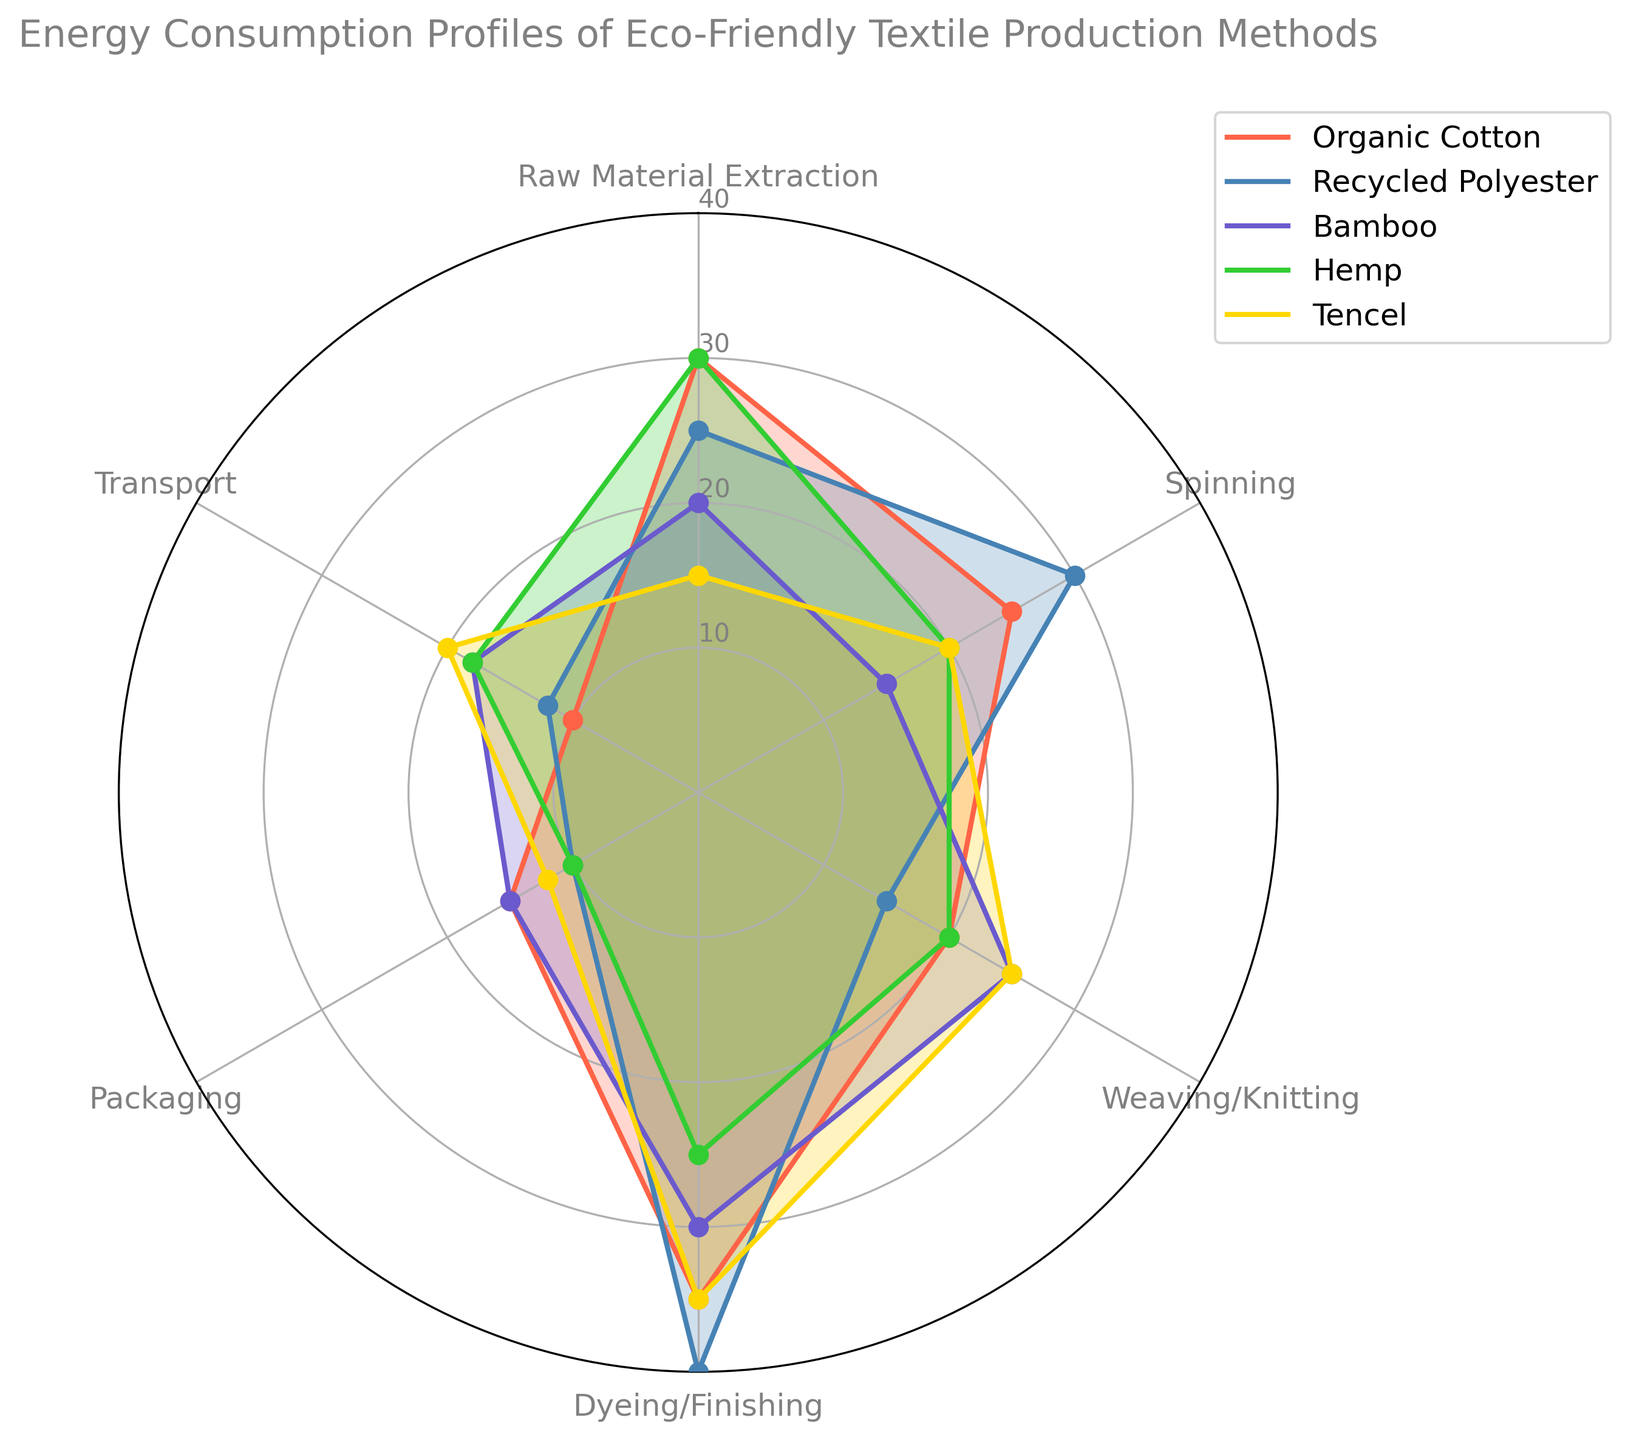What is the energy consumption for raw material extraction for Organic Cotton and Bamboo combined? The energy consumption for raw material extraction in Organic Cotton is 30 and for Bamboo, it is 20. Summing them up gives us 30 + 20 = 50.
Answer: 50 Which textile method has the highest energy consumption in Dyeing/Finishing? In Dyeing/Finishing, the energy consumptions are: Organic Cotton (35), Recycled Polyester (40), Bamboo (30), Hemp (25), Tencel (35). The highest value is 40 for Recycled Polyester.
Answer: Recycled Polyester How does the energy consumption of Tencel in Transport compare to Bamboo in the same process? Tencel has an energy consumption of 20 for Transport, whereas Bamboo has 18 for the same process. 20 is greater than 18.
Answer: Tencel has higher energy consumption What is the average energy consumption across all processes for Hemp? Adding all processes for Hemp (30 + 20 + 20 + 25 + 10 + 18) gives 123. Dividing by the number of processes (6) gives 123/6 = 20.5.
Answer: 20.5 Which textile method uses the least energy for spinning? The spinning energy consumptions are: Organic Cotton (25), Recycled Polyester (30), Bamboo (15), Hemp (20), Tencel (20). The lowest value is 15 for Bamboo.
Answer: Bamboo Compare the energy consumption in Weaving/Knitting between Organic Cotton and Tencel. Which one is higher? Organic Cotton has 20 and Tencel has 25 for Weaving/Knitting. 25 is greater than 20.
Answer: Tencel is higher For which method is the sum of energy consumption in Raw Material Extraction and Packaging the smallest? Summing Raw Material Extraction and Packaging for each method: Organic Cotton (30 + 15 = 45), Recycled Polyester (25 + 10 = 35), Bamboo (20 + 15 = 35), Hemp (30 + 10 = 40), Tencel (15 + 12 = 27). The smallest sum is 27 for Tencel.
Answer: Tencel Which process has the highest variability across all methods? We calculate the difference between the max and min values for each process. Raw Material Extraction (30-15=15), Spinning (30-15=15), Weaving/Knitting (25-20=5), Dyeing/Finishing (40-25=15), Packaging (15-10=5), Transport (20-10=10). Dyeing/Finishing has the highest variability with a range of 15.
Answer: Dyeing/Finishing In Packaging, is there any method that uses more than 15 units of energy? The energy consumptions for Packaging are: Organic Cotton (15), Recycled Polyester (10), Bamboo (15), Hemp (10), Tencel (12). None of these values exceed 15.
Answer: No If we combine the energy consumption of Dyeing/Finishing and Transport for Bamboo, how does it compare to Tencel in the same processes? For Bamboo, Dyeing/Finishing (30) + Transport (18) = 48. For Tencel, Dyeing/Finishing (35) + Transport (20) = 55. 55 is greater than 48.
Answer: Tencel is higher 